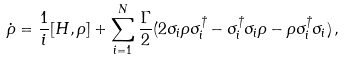<formula> <loc_0><loc_0><loc_500><loc_500>\dot { \rho } = \frac { 1 } { i } [ H , \rho ] + \sum _ { i = 1 } ^ { N } \frac { \Gamma } { 2 } ( 2 \sigma _ { i } \rho \sigma _ { i } ^ { \dagger } - \sigma _ { i } ^ { \dagger } \sigma _ { i } \rho - \rho \sigma _ { i } ^ { \dagger } \sigma _ { i } ) \, ,</formula> 